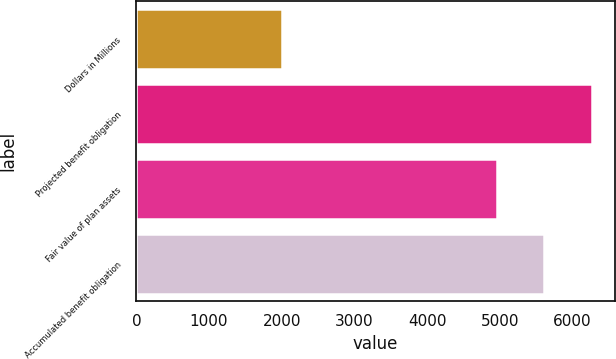<chart> <loc_0><loc_0><loc_500><loc_500><bar_chart><fcel>Dollars in Millions<fcel>Projected benefit obligation<fcel>Fair value of plan assets<fcel>Accumulated benefit obligation<nl><fcel>2009<fcel>6269<fcel>4963<fcel>5605<nl></chart> 